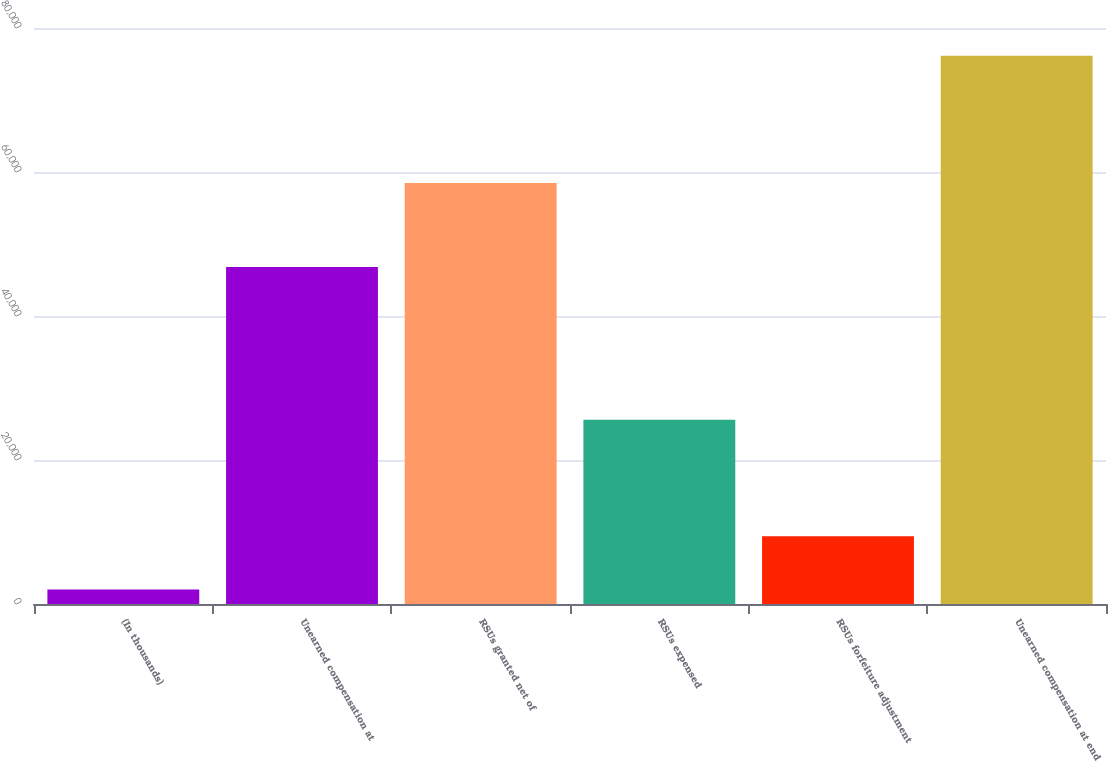<chart> <loc_0><loc_0><loc_500><loc_500><bar_chart><fcel>(In thousands)<fcel>Unearned compensation at<fcel>RSUs granted net of<fcel>RSUs expensed<fcel>RSUs forfeiture adjustment<fcel>Unearned compensation at end<nl><fcel>2010<fcel>46801<fcel>58462<fcel>25584<fcel>9422.9<fcel>76139<nl></chart> 